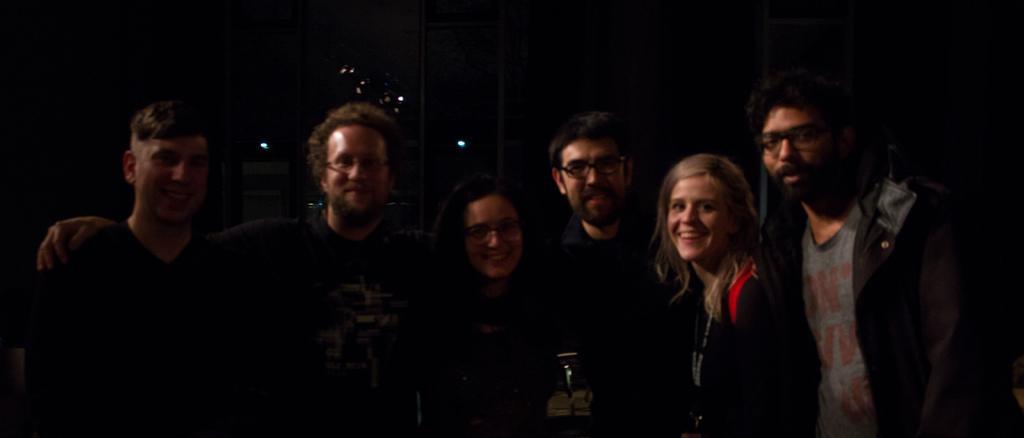Could you give a brief overview of what you see in this image? In the left side 2 men are standing and smiling. In the middle, a woman is smiling and in the right side a woman is also smiling, she wore coat. 